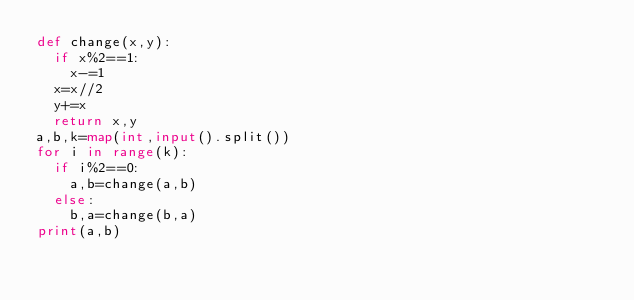<code> <loc_0><loc_0><loc_500><loc_500><_Python_>def change(x,y):
  if x%2==1:
    x-=1
  x=x//2
  y+=x
  return x,y
a,b,k=map(int,input().split())
for i in range(k):
  if i%2==0:
    a,b=change(a,b)
  else:
    b,a=change(b,a)
print(a,b)</code> 